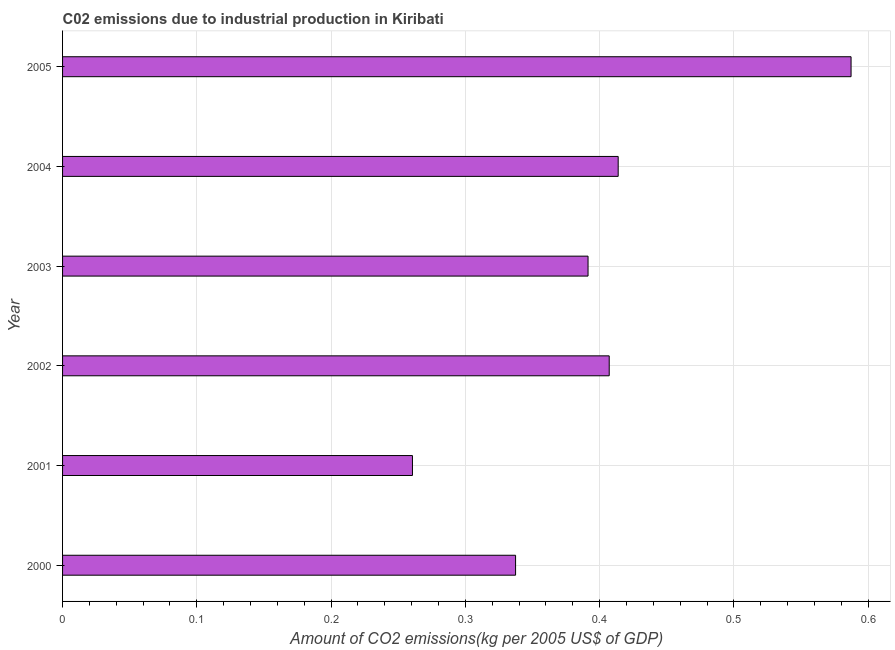Does the graph contain any zero values?
Offer a terse response. No. What is the title of the graph?
Keep it short and to the point. C02 emissions due to industrial production in Kiribati. What is the label or title of the X-axis?
Your answer should be compact. Amount of CO2 emissions(kg per 2005 US$ of GDP). What is the label or title of the Y-axis?
Provide a short and direct response. Year. What is the amount of co2 emissions in 2002?
Provide a short and direct response. 0.41. Across all years, what is the maximum amount of co2 emissions?
Keep it short and to the point. 0.59. Across all years, what is the minimum amount of co2 emissions?
Provide a short and direct response. 0.26. In which year was the amount of co2 emissions maximum?
Provide a succinct answer. 2005. In which year was the amount of co2 emissions minimum?
Your answer should be very brief. 2001. What is the sum of the amount of co2 emissions?
Offer a terse response. 2.4. What is the difference between the amount of co2 emissions in 2002 and 2005?
Keep it short and to the point. -0.18. What is the average amount of co2 emissions per year?
Ensure brevity in your answer.  0.4. What is the median amount of co2 emissions?
Your answer should be very brief. 0.4. What is the ratio of the amount of co2 emissions in 2001 to that in 2002?
Make the answer very short. 0.64. Is the difference between the amount of co2 emissions in 2002 and 2005 greater than the difference between any two years?
Provide a short and direct response. No. What is the difference between the highest and the second highest amount of co2 emissions?
Make the answer very short. 0.17. Is the sum of the amount of co2 emissions in 2002 and 2005 greater than the maximum amount of co2 emissions across all years?
Keep it short and to the point. Yes. What is the difference between the highest and the lowest amount of co2 emissions?
Ensure brevity in your answer.  0.33. How many bars are there?
Your answer should be very brief. 6. What is the difference between two consecutive major ticks on the X-axis?
Make the answer very short. 0.1. What is the Amount of CO2 emissions(kg per 2005 US$ of GDP) of 2000?
Ensure brevity in your answer.  0.34. What is the Amount of CO2 emissions(kg per 2005 US$ of GDP) in 2001?
Ensure brevity in your answer.  0.26. What is the Amount of CO2 emissions(kg per 2005 US$ of GDP) of 2002?
Offer a terse response. 0.41. What is the Amount of CO2 emissions(kg per 2005 US$ of GDP) of 2003?
Ensure brevity in your answer.  0.39. What is the Amount of CO2 emissions(kg per 2005 US$ of GDP) in 2004?
Provide a succinct answer. 0.41. What is the Amount of CO2 emissions(kg per 2005 US$ of GDP) in 2005?
Give a very brief answer. 0.59. What is the difference between the Amount of CO2 emissions(kg per 2005 US$ of GDP) in 2000 and 2001?
Keep it short and to the point. 0.08. What is the difference between the Amount of CO2 emissions(kg per 2005 US$ of GDP) in 2000 and 2002?
Keep it short and to the point. -0.07. What is the difference between the Amount of CO2 emissions(kg per 2005 US$ of GDP) in 2000 and 2003?
Your answer should be compact. -0.05. What is the difference between the Amount of CO2 emissions(kg per 2005 US$ of GDP) in 2000 and 2004?
Ensure brevity in your answer.  -0.08. What is the difference between the Amount of CO2 emissions(kg per 2005 US$ of GDP) in 2000 and 2005?
Give a very brief answer. -0.25. What is the difference between the Amount of CO2 emissions(kg per 2005 US$ of GDP) in 2001 and 2002?
Make the answer very short. -0.15. What is the difference between the Amount of CO2 emissions(kg per 2005 US$ of GDP) in 2001 and 2003?
Offer a terse response. -0.13. What is the difference between the Amount of CO2 emissions(kg per 2005 US$ of GDP) in 2001 and 2004?
Provide a short and direct response. -0.15. What is the difference between the Amount of CO2 emissions(kg per 2005 US$ of GDP) in 2001 and 2005?
Your response must be concise. -0.33. What is the difference between the Amount of CO2 emissions(kg per 2005 US$ of GDP) in 2002 and 2003?
Ensure brevity in your answer.  0.02. What is the difference between the Amount of CO2 emissions(kg per 2005 US$ of GDP) in 2002 and 2004?
Your answer should be compact. -0.01. What is the difference between the Amount of CO2 emissions(kg per 2005 US$ of GDP) in 2002 and 2005?
Provide a short and direct response. -0.18. What is the difference between the Amount of CO2 emissions(kg per 2005 US$ of GDP) in 2003 and 2004?
Give a very brief answer. -0.02. What is the difference between the Amount of CO2 emissions(kg per 2005 US$ of GDP) in 2003 and 2005?
Provide a succinct answer. -0.2. What is the difference between the Amount of CO2 emissions(kg per 2005 US$ of GDP) in 2004 and 2005?
Ensure brevity in your answer.  -0.17. What is the ratio of the Amount of CO2 emissions(kg per 2005 US$ of GDP) in 2000 to that in 2001?
Your answer should be compact. 1.29. What is the ratio of the Amount of CO2 emissions(kg per 2005 US$ of GDP) in 2000 to that in 2002?
Give a very brief answer. 0.83. What is the ratio of the Amount of CO2 emissions(kg per 2005 US$ of GDP) in 2000 to that in 2003?
Your answer should be compact. 0.86. What is the ratio of the Amount of CO2 emissions(kg per 2005 US$ of GDP) in 2000 to that in 2004?
Your answer should be compact. 0.81. What is the ratio of the Amount of CO2 emissions(kg per 2005 US$ of GDP) in 2000 to that in 2005?
Your answer should be compact. 0.57. What is the ratio of the Amount of CO2 emissions(kg per 2005 US$ of GDP) in 2001 to that in 2002?
Provide a succinct answer. 0.64. What is the ratio of the Amount of CO2 emissions(kg per 2005 US$ of GDP) in 2001 to that in 2003?
Offer a terse response. 0.67. What is the ratio of the Amount of CO2 emissions(kg per 2005 US$ of GDP) in 2001 to that in 2004?
Offer a very short reply. 0.63. What is the ratio of the Amount of CO2 emissions(kg per 2005 US$ of GDP) in 2001 to that in 2005?
Make the answer very short. 0.44. What is the ratio of the Amount of CO2 emissions(kg per 2005 US$ of GDP) in 2002 to that in 2005?
Ensure brevity in your answer.  0.69. What is the ratio of the Amount of CO2 emissions(kg per 2005 US$ of GDP) in 2003 to that in 2004?
Ensure brevity in your answer.  0.95. What is the ratio of the Amount of CO2 emissions(kg per 2005 US$ of GDP) in 2003 to that in 2005?
Give a very brief answer. 0.67. What is the ratio of the Amount of CO2 emissions(kg per 2005 US$ of GDP) in 2004 to that in 2005?
Keep it short and to the point. 0.7. 